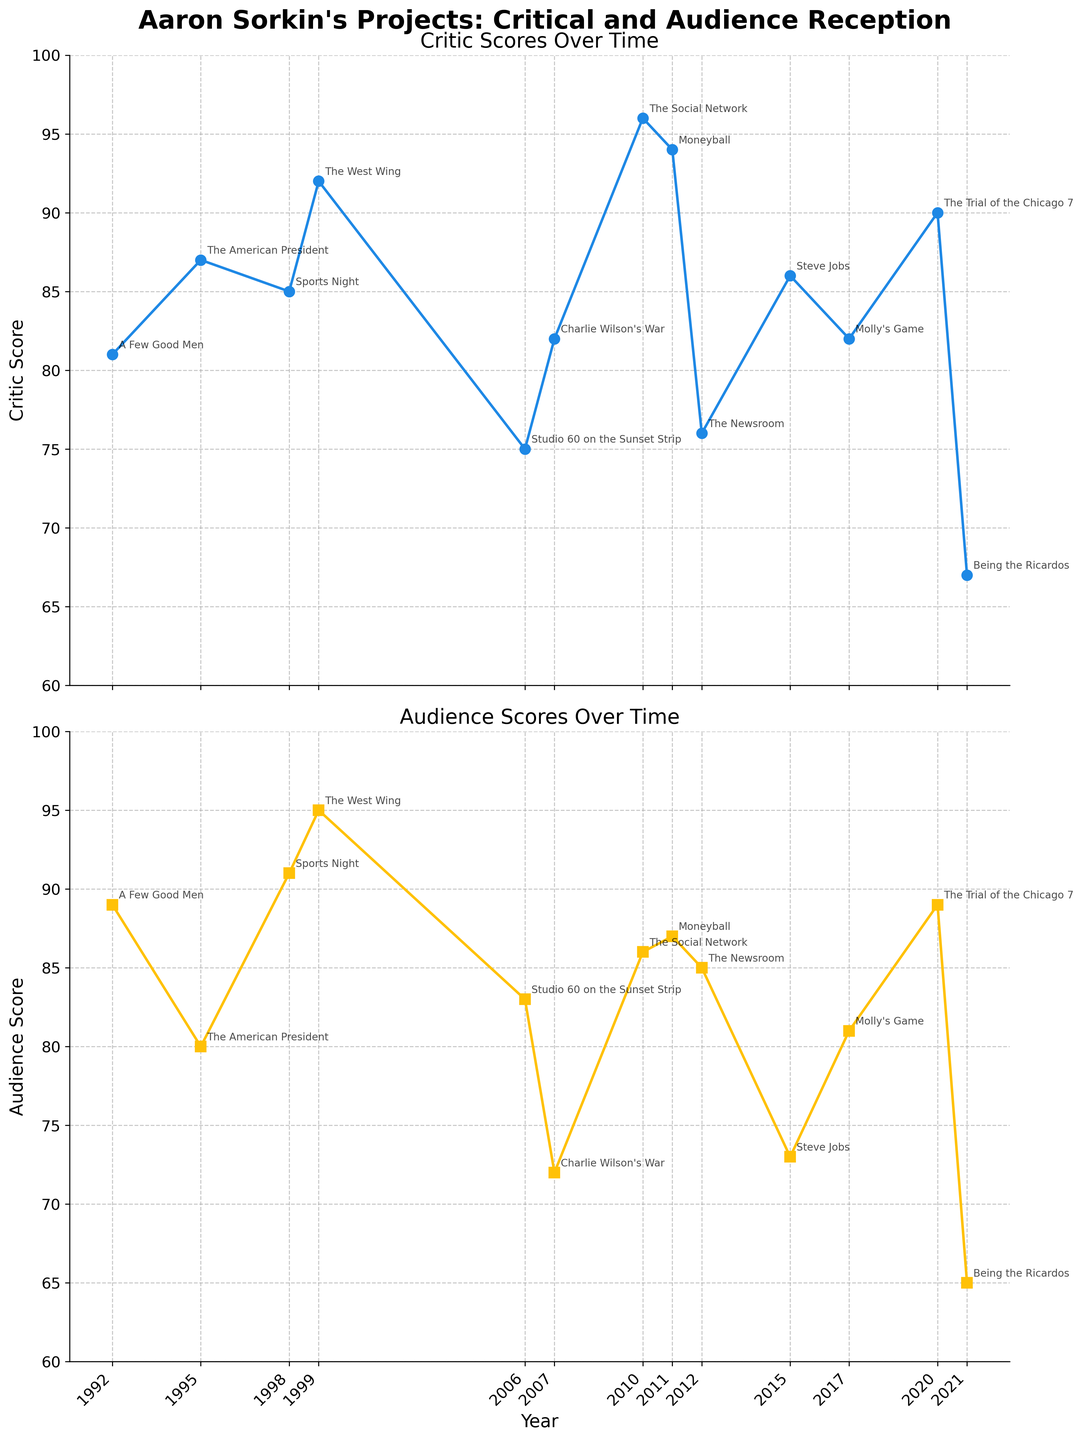What's the title of the first subplot? The title of the first subplot, which shows Critic Scores, is located at the top of the subplot and reads "Critic Scores Over Time".
Answer: Critic Scores Over Time What's the title of the second subplot? The title of the second subplot, which shows Audience Scores, is located at the top of the subplot and reads "Audience Scores Over Time".
Answer: Audience Scores Over Time Which project has the highest Critic Score? By observing the plot of Critic Scores Over Time, the project with the highest score appears at the peak point of the subplot. This project is "The Social Network".
Answer: The Social Network Which year has the lowest Audience Score? By examining the plot of Audience Scores Over Time, the year with the lowest Audience Score corresponds to the lowest point on the subplot. This year is 2021 for "Being the Ricardos".
Answer: 2021 What's the average Critic Score of Aaron Sorkin's projects from 2010 to 2020? Calculate the average Critic Score by summing the scores from 2010 to 2020 and dividing by the number of projects. The scores are 96 ("The Social Network"), 94 ("Moneyball"), 76 ("The Newsroom"), 86 ("Steve Jobs"), 82 ("Molly's Game"), and 90 ("The Trial of the Chicago 7"). Sum = 96 + 94 + 76 + 86 + 82 + 90 = 524, number of projects = 6, so the average is 524/6 ≈ 87.33
Answer: ≈ 87.33 What's the difference between the highest and lowest Audience Scores? Find the highest and lowest Audience Scores from the Audience Scores Over Time subplot. Highest: 95 ("The West Wing"), Lowest: 65 ("Being the Ricardos"). Difference = 95 - 65 = 30
Answer: 30 Which project shows the biggest discrepancy between Critic and Audience Scores? To find the biggest discrepancy, calculate the absolute difference between Critic and Audience Scores for each project and identify the largest value. The differences are: "A Few Good Men" (8), "The American President" (7), "Sports Night" (6), "The West Wing" (3), "Studio 60 on the Sunset Strip" (8), "Charlie Wilson's War" (10), "The Social Network" (10), "Moneyball" (7), "The Newsroom" (9), "Steve Jobs" (13), "Molly's Game" (1), "The Trial of the Chicago 7" (1), "Being the Ricardos" (2). The largest discrepancy is for "Steve Jobs" (13).
Answer: Steve Jobs How does the Audience Score for "The West Wing" compare to "The Newsroom"? Look at the Audience Scores for both projects. "The West Wing" has an Audience Score of 95, while "The Newsroom" has 85. Comparing them, "The West Wing" has a higher Audience Score.
Answer: The West Wing has a higher Audience Score 